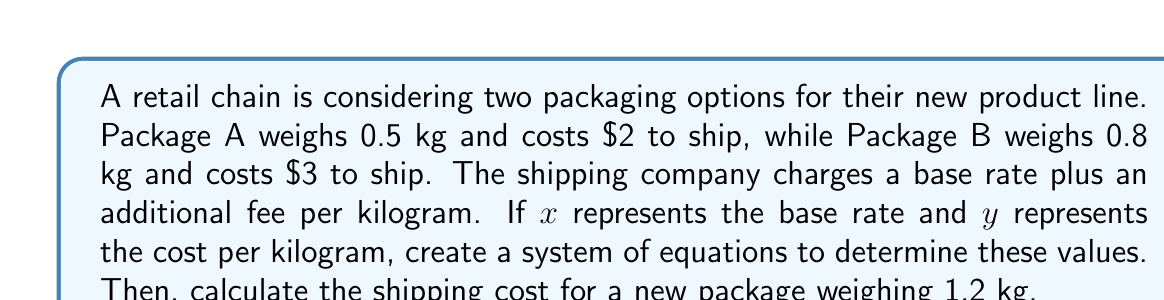Provide a solution to this math problem. Let's approach this step-by-step:

1) First, we need to set up our system of equations based on the given information:

   For Package A: $x + 0.5y = 2$
   For Package B: $x + 0.8y = 3$

2) Now we have a system of two equations with two unknowns:

   $$\begin{cases}
   x + 0.5y = 2 \\
   x + 0.8y = 3
   \end{cases}$$

3) To solve this, let's subtract the first equation from the second:

   $(x + 0.8y) - (x + 0.5y) = 3 - 2$
   $0.3y = 1$

4) Solve for $y$:

   $y = \frac{1}{0.3} = \frac{10}{3} \approx 3.33$

5) Now substitute this value of $y$ back into either of the original equations. Let's use the first one:

   $x + 0.5(3.33) = 2$
   $x + 1.67 = 2$
   $x = 0.33$

6) So, the base rate ($x$) is $0.33, and the cost per kilogram ($y$) is $3.33.

7) To calculate the shipping cost for a new package weighing 1.2 kg, we use the formula:

   Cost = Base rate + (Weight × Cost per kg)
   Cost = $0.33 + (1.2 × $3.33)
   Cost = $0.33 + $4.00
   Cost = $4.33
Answer: The shipping cost for a package weighing 1.2 kg would be $4.33. 